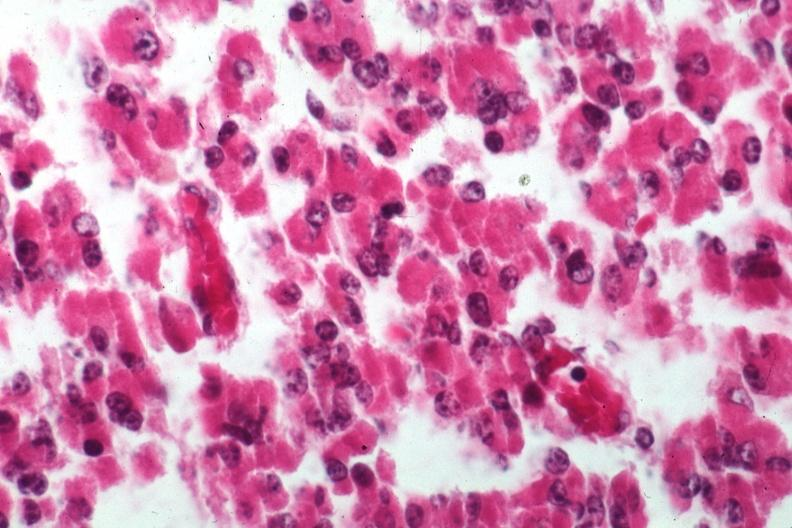s endocrine present?
Answer the question using a single word or phrase. Yes 